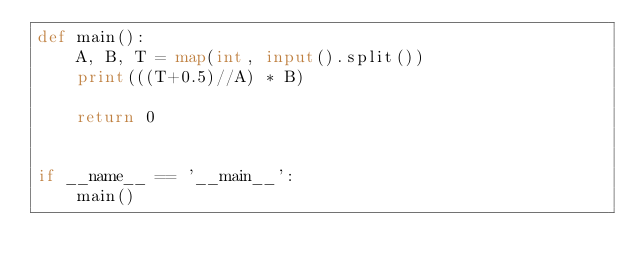Convert code to text. <code><loc_0><loc_0><loc_500><loc_500><_Python_>def main():
    A, B, T = map(int, input().split())
    print(((T+0.5)//A) * B)

    return 0


if __name__ == '__main__':
    main()</code> 